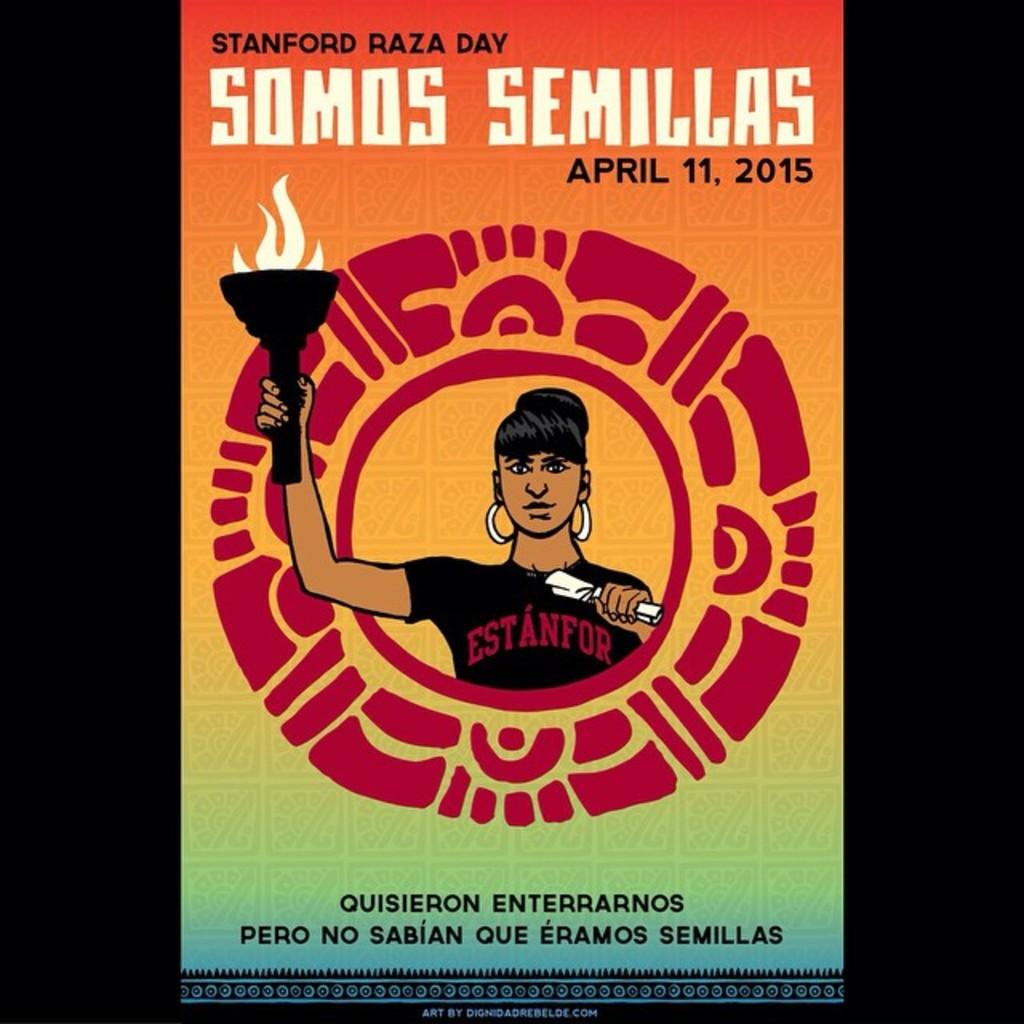<image>
Present a compact description of the photo's key features. A flyer shows a woman holding a torch is for Stanford Raza Day. 